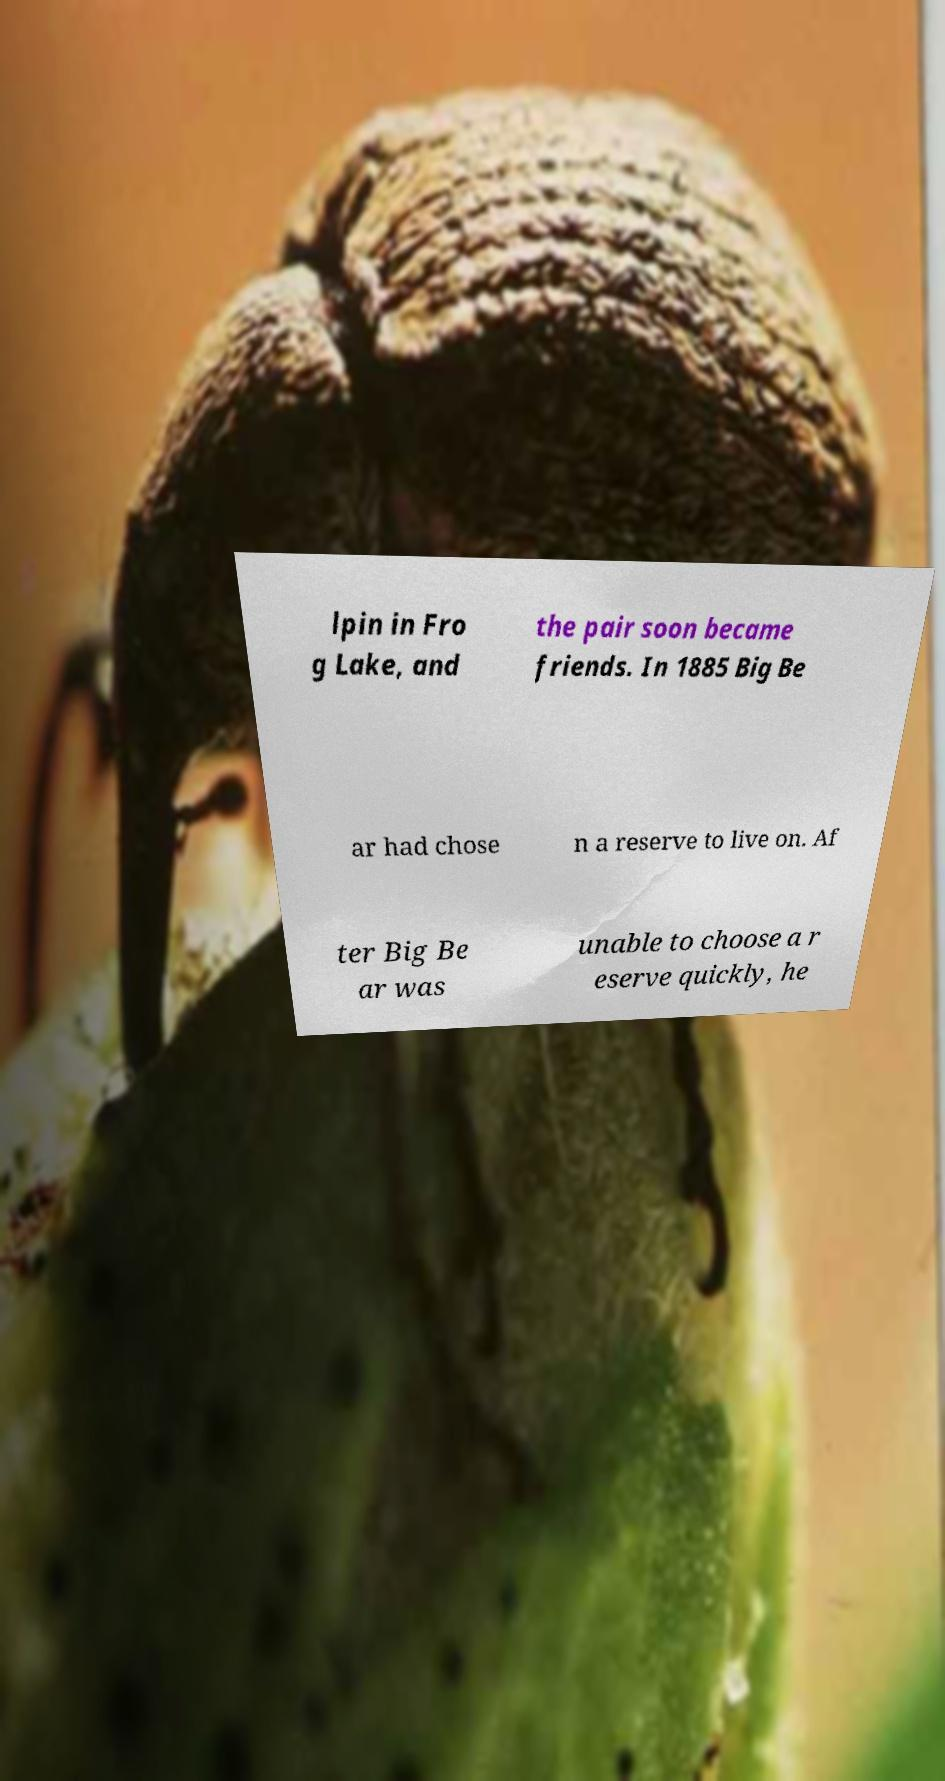What messages or text are displayed in this image? I need them in a readable, typed format. lpin in Fro g Lake, and the pair soon became friends. In 1885 Big Be ar had chose n a reserve to live on. Af ter Big Be ar was unable to choose a r eserve quickly, he 